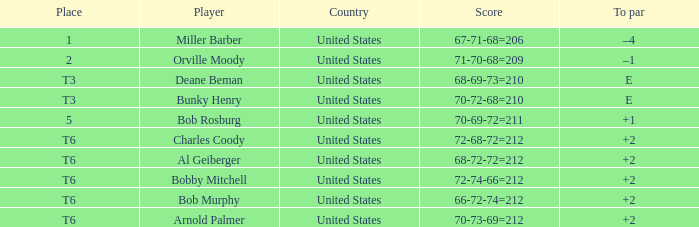Who is the player with a t6 place and a 72-68-72=212 score? Charles Coody. 